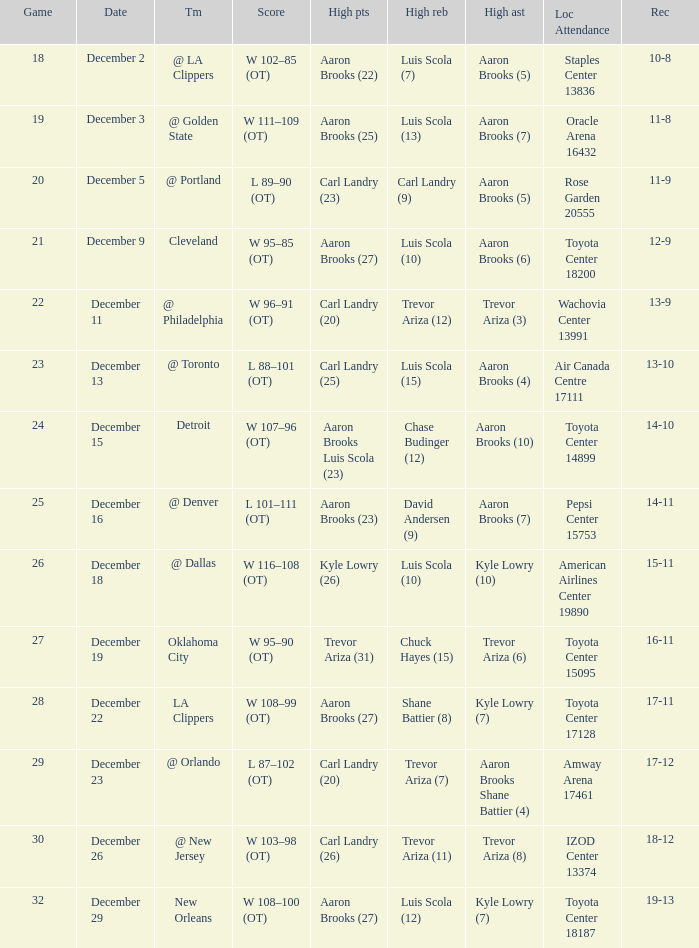What's the end score of the game where Shane Battier (8) did the high rebounds? W 108–99 (OT). 